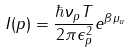<formula> <loc_0><loc_0><loc_500><loc_500>I ( p ) = \frac { \hbar { \nu } _ { p } T } { 2 \pi \epsilon _ { p } ^ { 2 } } e ^ { \beta \mu _ { a } }</formula> 